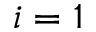<formula> <loc_0><loc_0><loc_500><loc_500>i = 1</formula> 